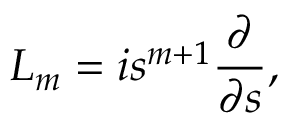<formula> <loc_0><loc_0><loc_500><loc_500>{ L } _ { m } = i s ^ { m + 1 } \frac { \partial } { \partial s } , \,</formula> 